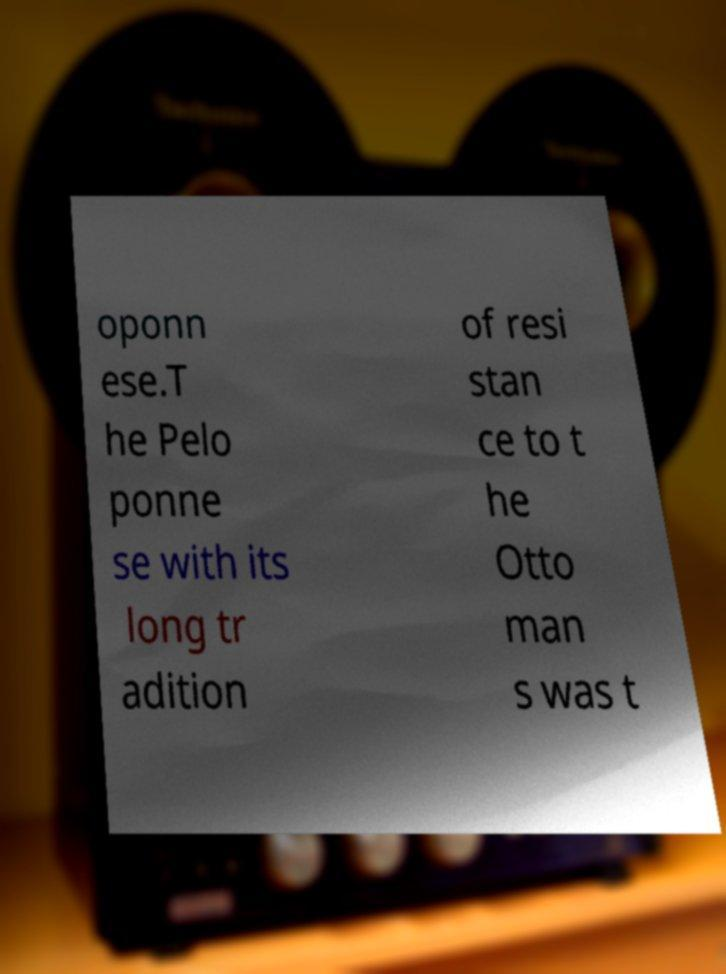Can you read and provide the text displayed in the image?This photo seems to have some interesting text. Can you extract and type it out for me? oponn ese.T he Pelo ponne se with its long tr adition of resi stan ce to t he Otto man s was t 